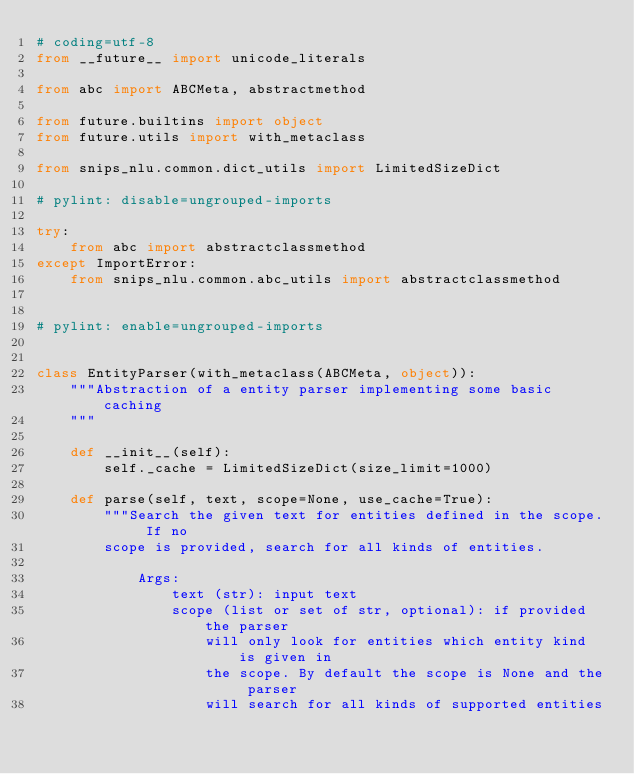Convert code to text. <code><loc_0><loc_0><loc_500><loc_500><_Python_># coding=utf-8
from __future__ import unicode_literals

from abc import ABCMeta, abstractmethod

from future.builtins import object
from future.utils import with_metaclass

from snips_nlu.common.dict_utils import LimitedSizeDict

# pylint: disable=ungrouped-imports

try:
    from abc import abstractclassmethod
except ImportError:
    from snips_nlu.common.abc_utils import abstractclassmethod


# pylint: enable=ungrouped-imports


class EntityParser(with_metaclass(ABCMeta, object)):
    """Abstraction of a entity parser implementing some basic caching
    """

    def __init__(self):
        self._cache = LimitedSizeDict(size_limit=1000)

    def parse(self, text, scope=None, use_cache=True):
        """Search the given text for entities defined in the scope. If no
        scope is provided, search for all kinds of entities.

            Args:
                text (str): input text
                scope (list or set of str, optional): if provided the parser
                    will only look for entities which entity kind is given in
                    the scope. By default the scope is None and the parser
                    will search for all kinds of supported entities</code> 